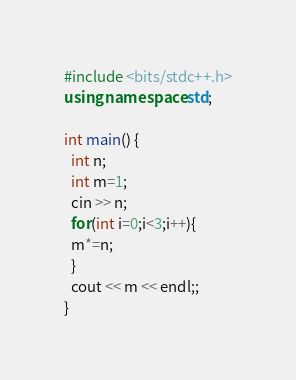<code> <loc_0><loc_0><loc_500><loc_500><_C++_>#include <bits/stdc++.h>
using namespace std;

int main() {
  int n;
  int m=1;
  cin >> n;
  for(int i=0;i<3;i++){
  m*=n;
  } 
  cout << m << endl;; 
}</code> 